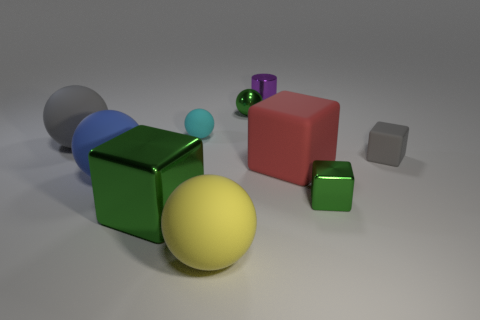Do the small metallic ball and the small shiny cube have the same color?
Offer a terse response. Yes. There is a big block that is on the left side of the tiny purple metallic object; does it have the same color as the shiny ball?
Keep it short and to the point. Yes. What shape is the tiny object that is the same color as the tiny metal sphere?
Your answer should be compact. Cube. What number of big blue rubber spheres are left of the large red thing?
Your answer should be very brief. 1. The blue object is what size?
Offer a terse response. Large. What color is the rubber cube that is the same size as the cylinder?
Provide a succinct answer. Gray. Is there a block that has the same color as the large metal thing?
Offer a terse response. Yes. What is the blue object made of?
Your answer should be compact. Rubber. How many small cyan things are there?
Give a very brief answer. 1. There is a big matte sphere behind the tiny gray thing; is it the same color as the rubber object to the right of the small green block?
Make the answer very short. Yes. 